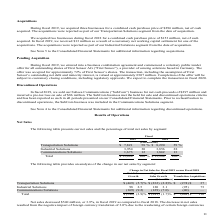According to Te Connectivity's financial document, What was the total net sales in 2019? According to the financial document, $ 13,448 (in millions). The relevant text states: "Total $ 13,448 100 % $ 13,988 100 %..." Also, What was the total Transportation Solutions sales in 2018? According to the financial document, $ 8,290 (in millions). The relevant text states: "Transportation Solutions $ 7,821 58 % $ 8,290 59 %..." Also, What are the segments for which the net sales are presented in the table? The document contains multiple relevant values: Transportation Solutions, Industrial Solutions, Communications Solutions. From the document: "Transportation Solutions $ 7,821 58 % $ 8,290 59 % Industrial Solutions 3,954 30 3,856 28 Communications Solutions 1,673 12 1,842 13..." Additionally, In which year was Industrial Solutions larger? According to the financial document, 2019. The relevant text states: "2019 2018..." Also, can you calculate: What was the change in Industrial Solutions in 2019 from 2018? Based on the calculation: 3,954-3,856, the result is 98 (in millions). This is based on the information: "Industrial Solutions 3,954 30 3,856 28 Industrial Solutions 3,954 30 3,856 28..." The key data points involved are: 3,856, 3,954. Also, can you calculate: What was the percentage change in Industrial Solutions in 2019 from 2018? To answer this question, I need to perform calculations using the financial data. The calculation is: (3,954-3,856)/3,856, which equals 2.54 (percentage). This is based on the information: "Industrial Solutions 3,954 30 3,856 28 Industrial Solutions 3,954 30 3,856 28..." The key data points involved are: 3,856, 3,954. 